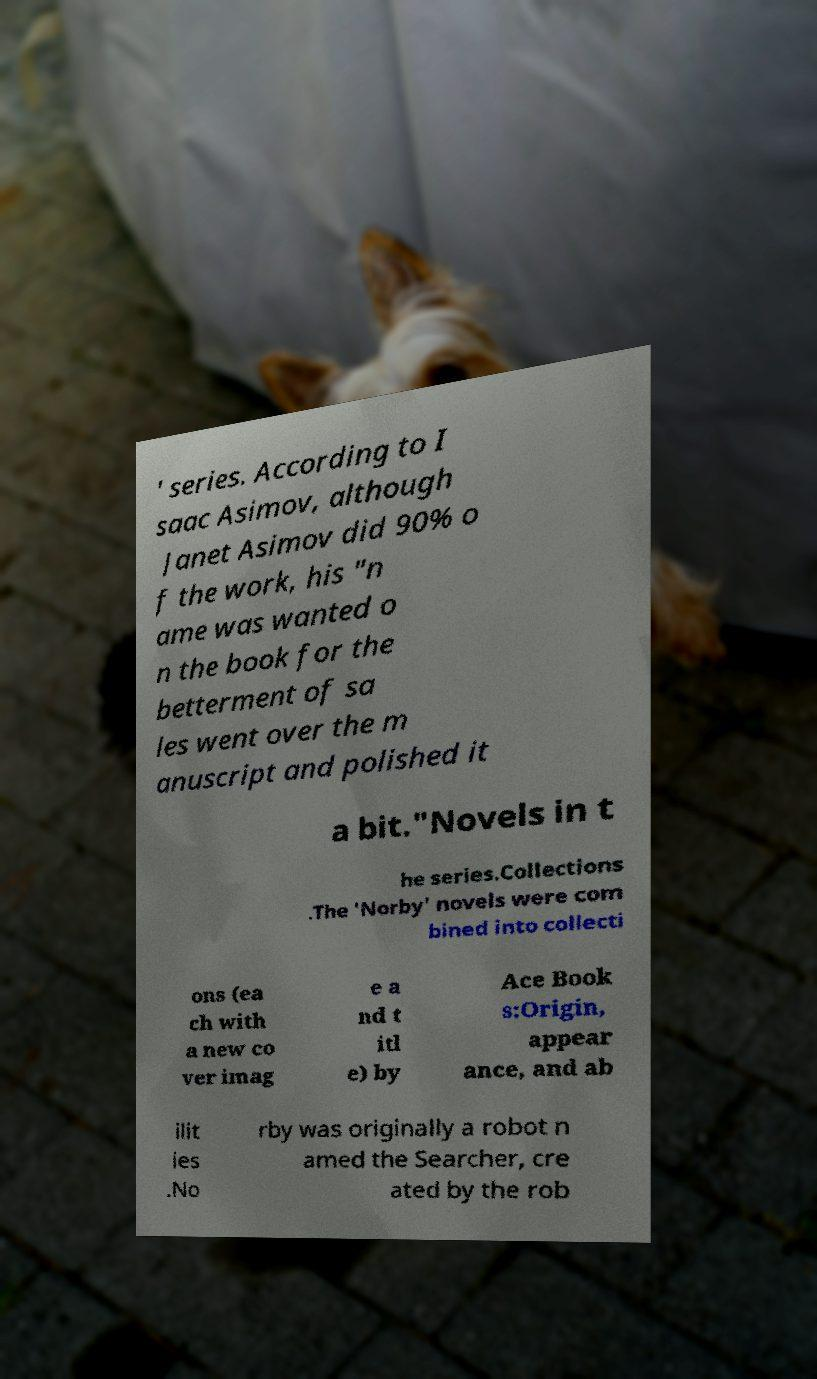Could you extract and type out the text from this image? ' series. According to I saac Asimov, although Janet Asimov did 90% o f the work, his "n ame was wanted o n the book for the betterment of sa les went over the m anuscript and polished it a bit."Novels in t he series.Collections .The 'Norby' novels were com bined into collecti ons (ea ch with a new co ver imag e a nd t itl e) by Ace Book s:Origin, appear ance, and ab ilit ies .No rby was originally a robot n amed the Searcher, cre ated by the rob 